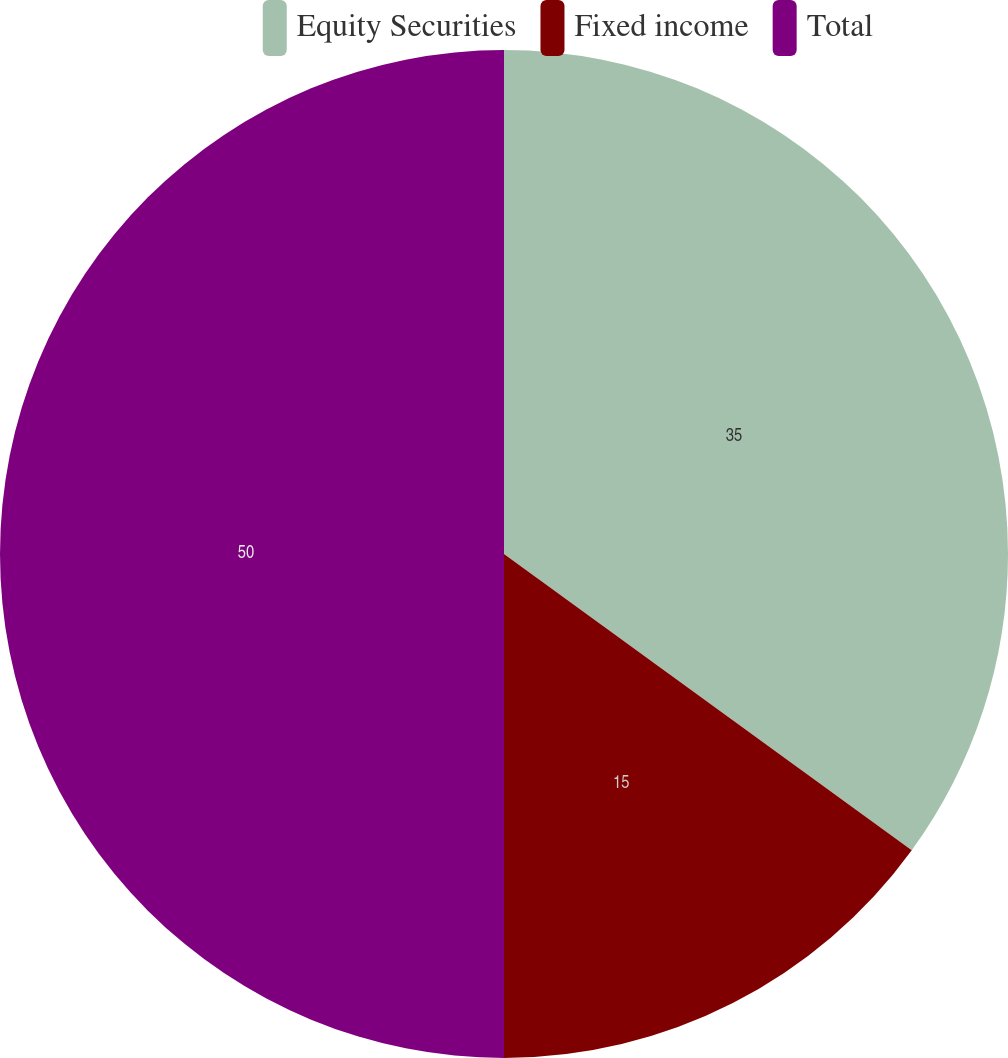Convert chart. <chart><loc_0><loc_0><loc_500><loc_500><pie_chart><fcel>Equity Securities<fcel>Fixed income<fcel>Total<nl><fcel>35.0%<fcel>15.0%<fcel>50.0%<nl></chart> 